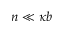Convert formula to latex. <formula><loc_0><loc_0><loc_500><loc_500>n \ll \kappa b</formula> 